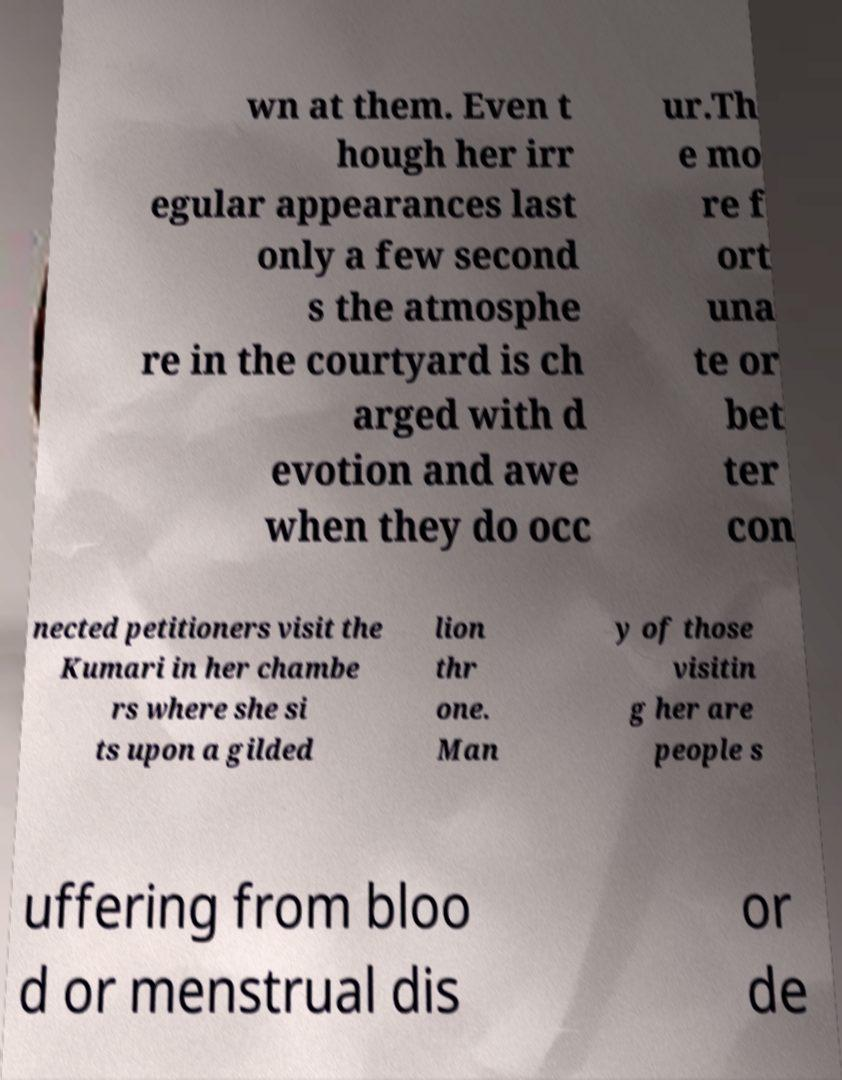I need the written content from this picture converted into text. Can you do that? wn at them. Even t hough her irr egular appearances last only a few second s the atmosphe re in the courtyard is ch arged with d evotion and awe when they do occ ur.Th e mo re f ort una te or bet ter con nected petitioners visit the Kumari in her chambe rs where she si ts upon a gilded lion thr one. Man y of those visitin g her are people s uffering from bloo d or menstrual dis or de 